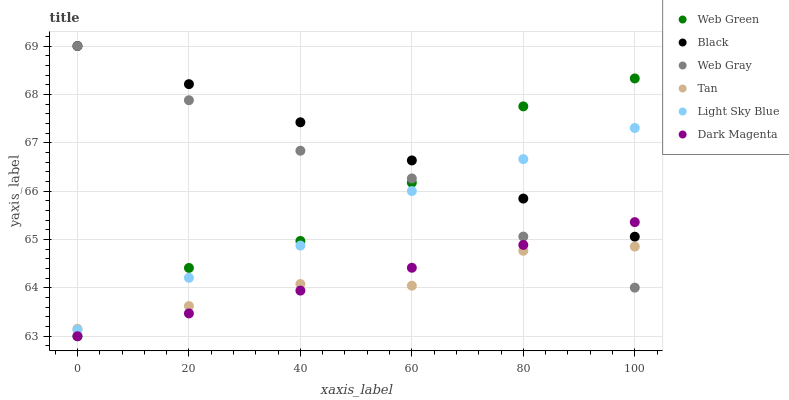Does Tan have the minimum area under the curve?
Answer yes or no. Yes. Does Black have the maximum area under the curve?
Answer yes or no. Yes. Does Dark Magenta have the minimum area under the curve?
Answer yes or no. No. Does Dark Magenta have the maximum area under the curve?
Answer yes or no. No. Is Dark Magenta the smoothest?
Answer yes or no. Yes. Is Web Green the roughest?
Answer yes or no. Yes. Is Web Green the smoothest?
Answer yes or no. No. Is Dark Magenta the roughest?
Answer yes or no. No. Does Dark Magenta have the lowest value?
Answer yes or no. Yes. Does Light Sky Blue have the lowest value?
Answer yes or no. No. Does Black have the highest value?
Answer yes or no. Yes. Does Dark Magenta have the highest value?
Answer yes or no. No. Is Tan less than Black?
Answer yes or no. Yes. Is Light Sky Blue greater than Dark Magenta?
Answer yes or no. Yes. Does Black intersect Dark Magenta?
Answer yes or no. Yes. Is Black less than Dark Magenta?
Answer yes or no. No. Is Black greater than Dark Magenta?
Answer yes or no. No. Does Tan intersect Black?
Answer yes or no. No. 